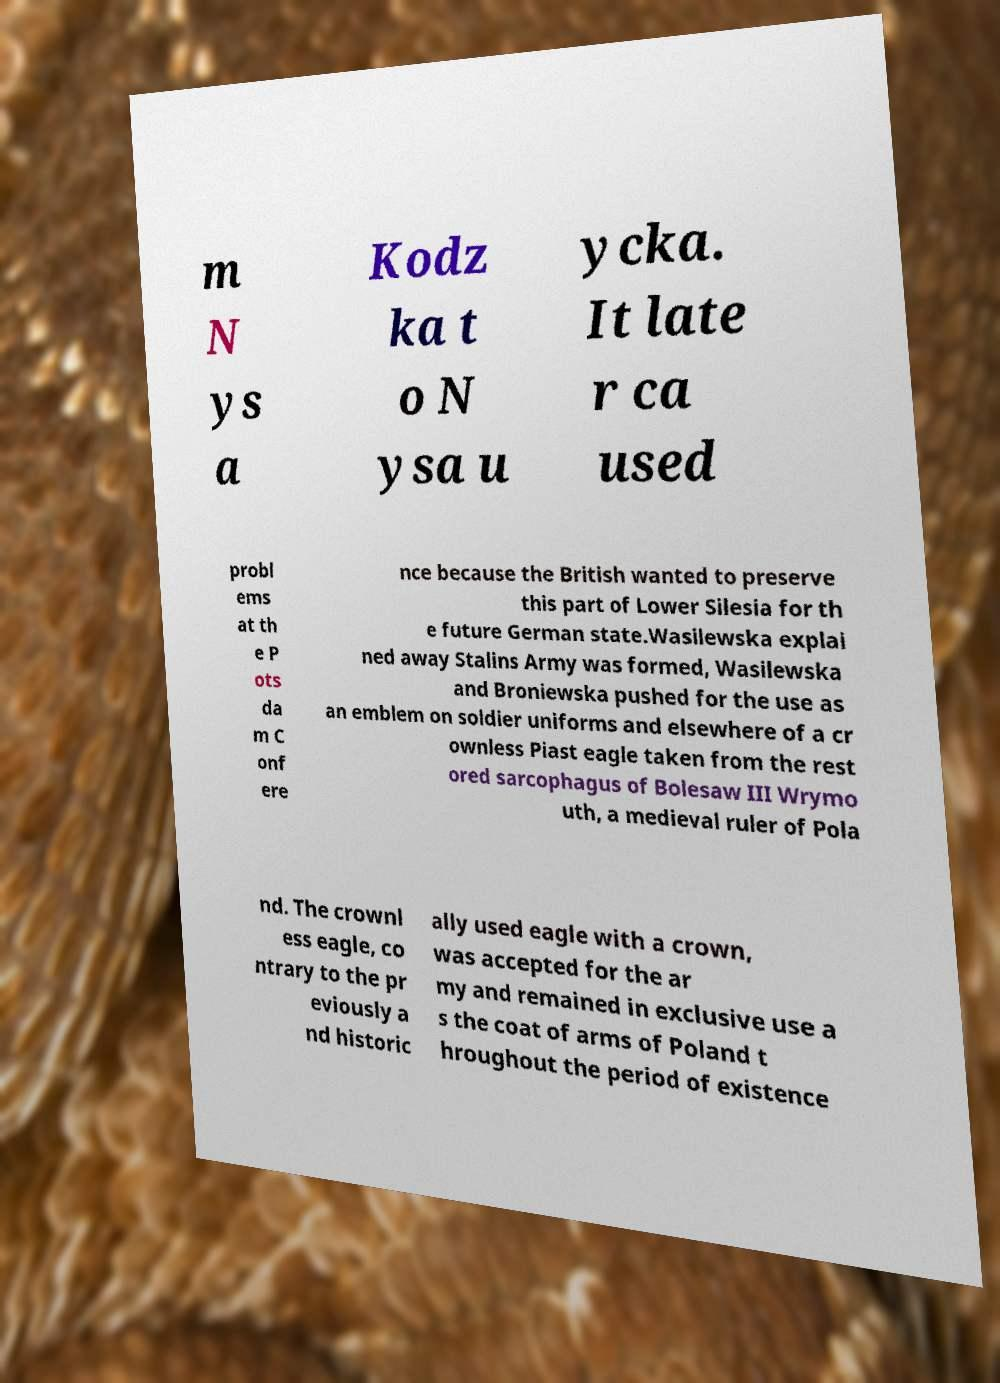Could you extract and type out the text from this image? m N ys a Kodz ka t o N ysa u ycka. It late r ca used probl ems at th e P ots da m C onf ere nce because the British wanted to preserve this part of Lower Silesia for th e future German state.Wasilewska explai ned away Stalins Army was formed, Wasilewska and Broniewska pushed for the use as an emblem on soldier uniforms and elsewhere of a cr ownless Piast eagle taken from the rest ored sarcophagus of Bolesaw III Wrymo uth, a medieval ruler of Pola nd. The crownl ess eagle, co ntrary to the pr eviously a nd historic ally used eagle with a crown, was accepted for the ar my and remained in exclusive use a s the coat of arms of Poland t hroughout the period of existence 